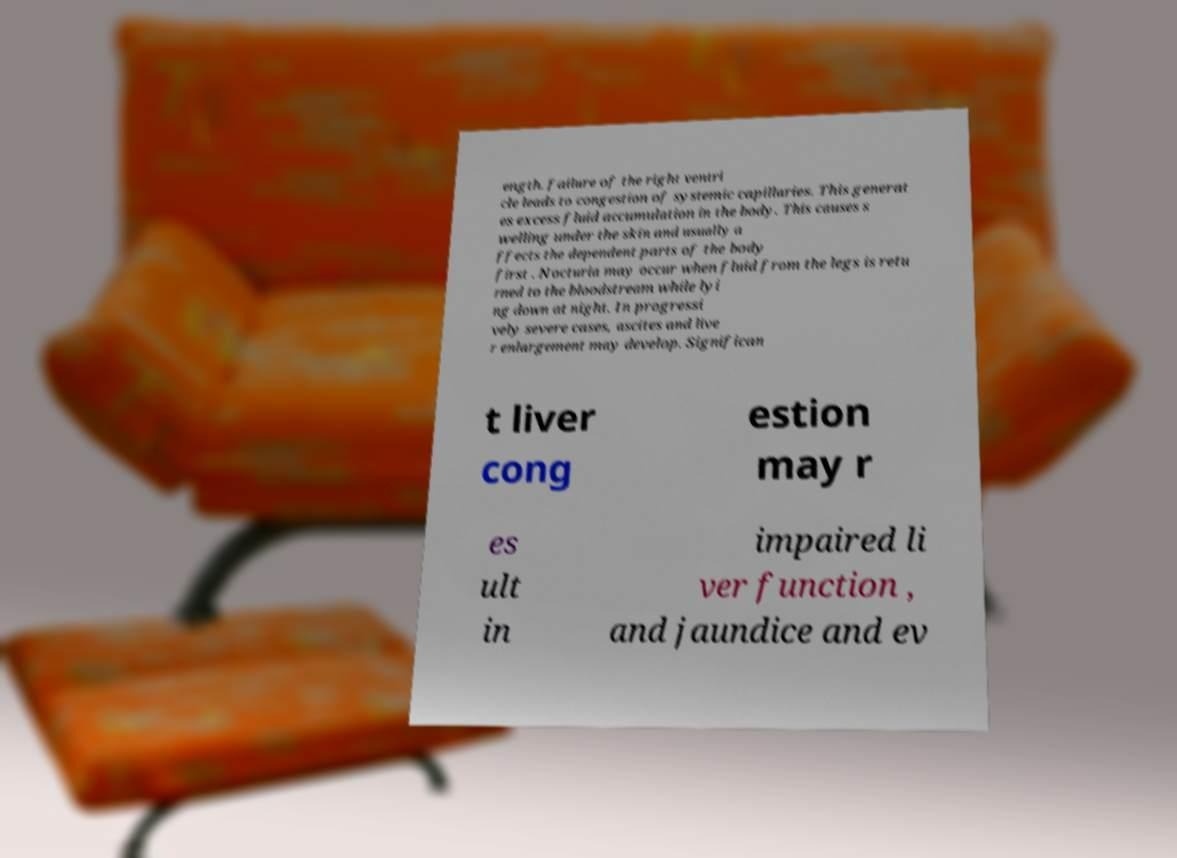Please read and relay the text visible in this image. What does it say? ength. failure of the right ventri cle leads to congestion of systemic capillaries. This generat es excess fluid accumulation in the body. This causes s welling under the skin and usually a ffects the dependent parts of the body first . Nocturia may occur when fluid from the legs is retu rned to the bloodstream while lyi ng down at night. In progressi vely severe cases, ascites and live r enlargement may develop. Significan t liver cong estion may r es ult in impaired li ver function , and jaundice and ev 